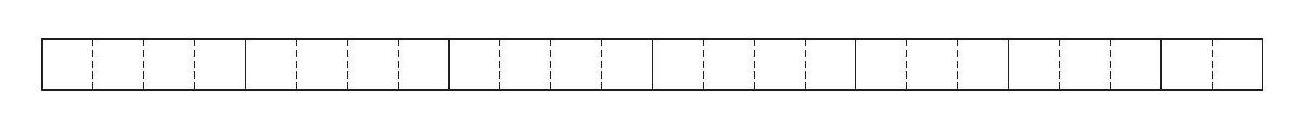If the perimeter needs to be minimized, can any of the smaller rectangles be left out to achieve this? No, each of the smaller rectangles must be used as we are tasked with rearranging all the given rectangles. Leaving any out would not satisfy the conditions of the problem. By strategically arranging all the pieces, we can minimize the new rectangle's perimeter. 